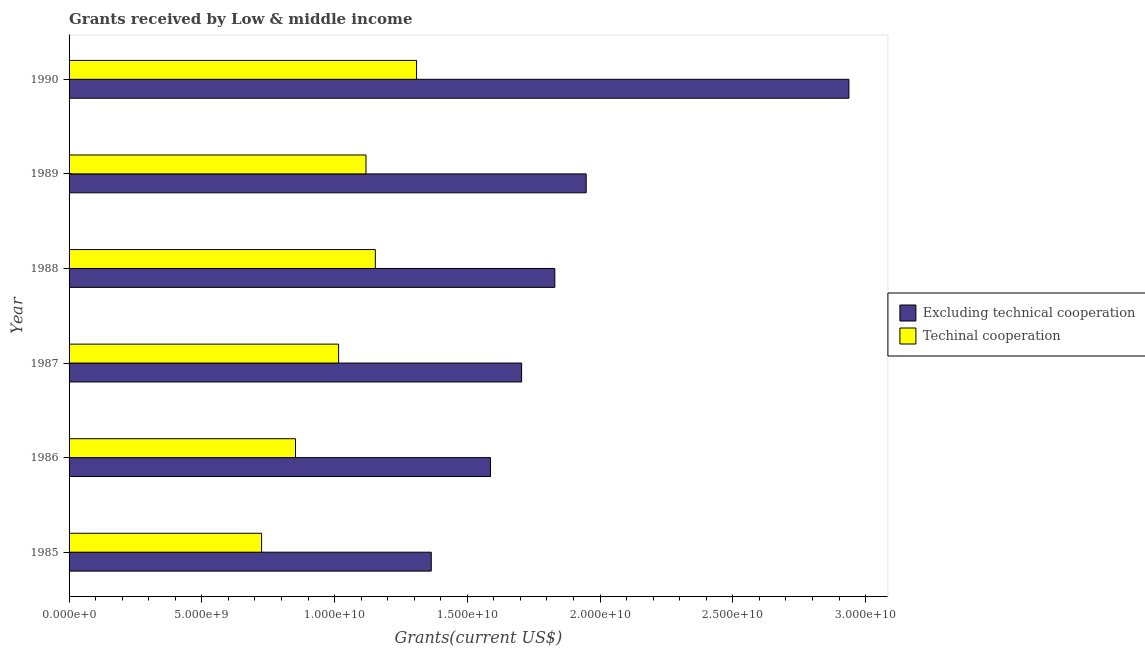How many different coloured bars are there?
Your response must be concise. 2. How many groups of bars are there?
Your answer should be very brief. 6. In how many cases, is the number of bars for a given year not equal to the number of legend labels?
Your response must be concise. 0. What is the amount of grants received(including technical cooperation) in 1988?
Keep it short and to the point. 1.15e+1. Across all years, what is the maximum amount of grants received(including technical cooperation)?
Your answer should be very brief. 1.31e+1. Across all years, what is the minimum amount of grants received(excluding technical cooperation)?
Provide a succinct answer. 1.36e+1. In which year was the amount of grants received(including technical cooperation) maximum?
Provide a short and direct response. 1990. What is the total amount of grants received(including technical cooperation) in the graph?
Offer a very short reply. 6.17e+1. What is the difference between the amount of grants received(including technical cooperation) in 1985 and that in 1989?
Ensure brevity in your answer.  -3.93e+09. What is the difference between the amount of grants received(excluding technical cooperation) in 1985 and the amount of grants received(including technical cooperation) in 1990?
Your response must be concise. 5.54e+08. What is the average amount of grants received(excluding technical cooperation) per year?
Provide a succinct answer. 1.89e+1. In the year 1989, what is the difference between the amount of grants received(including technical cooperation) and amount of grants received(excluding technical cooperation)?
Provide a succinct answer. -8.29e+09. What is the ratio of the amount of grants received(excluding technical cooperation) in 1986 to that in 1990?
Make the answer very short. 0.54. Is the amount of grants received(including technical cooperation) in 1986 less than that in 1989?
Keep it short and to the point. Yes. Is the difference between the amount of grants received(including technical cooperation) in 1989 and 1990 greater than the difference between the amount of grants received(excluding technical cooperation) in 1989 and 1990?
Your answer should be very brief. Yes. What is the difference between the highest and the second highest amount of grants received(excluding technical cooperation)?
Ensure brevity in your answer.  9.90e+09. What is the difference between the highest and the lowest amount of grants received(excluding technical cooperation)?
Offer a terse response. 1.57e+1. Is the sum of the amount of grants received(including technical cooperation) in 1987 and 1990 greater than the maximum amount of grants received(excluding technical cooperation) across all years?
Give a very brief answer. No. What does the 1st bar from the top in 1987 represents?
Keep it short and to the point. Techinal cooperation. What does the 2nd bar from the bottom in 1988 represents?
Your answer should be compact. Techinal cooperation. How many bars are there?
Your answer should be compact. 12. How many years are there in the graph?
Provide a short and direct response. 6. Does the graph contain any zero values?
Offer a very short reply. No. Does the graph contain grids?
Ensure brevity in your answer.  No. Where does the legend appear in the graph?
Your answer should be very brief. Center right. What is the title of the graph?
Offer a terse response. Grants received by Low & middle income. Does "Largest city" appear as one of the legend labels in the graph?
Ensure brevity in your answer.  No. What is the label or title of the X-axis?
Make the answer very short. Grants(current US$). What is the Grants(current US$) in Excluding technical cooperation in 1985?
Provide a short and direct response. 1.36e+1. What is the Grants(current US$) in Techinal cooperation in 1985?
Give a very brief answer. 7.25e+09. What is the Grants(current US$) in Excluding technical cooperation in 1986?
Your answer should be compact. 1.59e+1. What is the Grants(current US$) in Techinal cooperation in 1986?
Your answer should be very brief. 8.53e+09. What is the Grants(current US$) in Excluding technical cooperation in 1987?
Give a very brief answer. 1.70e+1. What is the Grants(current US$) of Techinal cooperation in 1987?
Provide a succinct answer. 1.02e+1. What is the Grants(current US$) in Excluding technical cooperation in 1988?
Give a very brief answer. 1.83e+1. What is the Grants(current US$) in Techinal cooperation in 1988?
Your response must be concise. 1.15e+1. What is the Grants(current US$) of Excluding technical cooperation in 1989?
Offer a terse response. 1.95e+1. What is the Grants(current US$) in Techinal cooperation in 1989?
Make the answer very short. 1.12e+1. What is the Grants(current US$) in Excluding technical cooperation in 1990?
Offer a terse response. 2.94e+1. What is the Grants(current US$) of Techinal cooperation in 1990?
Keep it short and to the point. 1.31e+1. Across all years, what is the maximum Grants(current US$) in Excluding technical cooperation?
Ensure brevity in your answer.  2.94e+1. Across all years, what is the maximum Grants(current US$) in Techinal cooperation?
Provide a short and direct response. 1.31e+1. Across all years, what is the minimum Grants(current US$) of Excluding technical cooperation?
Offer a terse response. 1.36e+1. Across all years, what is the minimum Grants(current US$) of Techinal cooperation?
Your answer should be compact. 7.25e+09. What is the total Grants(current US$) of Excluding technical cooperation in the graph?
Ensure brevity in your answer.  1.14e+11. What is the total Grants(current US$) of Techinal cooperation in the graph?
Give a very brief answer. 6.17e+1. What is the difference between the Grants(current US$) of Excluding technical cooperation in 1985 and that in 1986?
Your answer should be compact. -2.23e+09. What is the difference between the Grants(current US$) in Techinal cooperation in 1985 and that in 1986?
Offer a very short reply. -1.28e+09. What is the difference between the Grants(current US$) in Excluding technical cooperation in 1985 and that in 1987?
Provide a short and direct response. -3.40e+09. What is the difference between the Grants(current US$) of Techinal cooperation in 1985 and that in 1987?
Make the answer very short. -2.90e+09. What is the difference between the Grants(current US$) in Excluding technical cooperation in 1985 and that in 1988?
Provide a short and direct response. -4.65e+09. What is the difference between the Grants(current US$) of Techinal cooperation in 1985 and that in 1988?
Make the answer very short. -4.28e+09. What is the difference between the Grants(current US$) in Excluding technical cooperation in 1985 and that in 1989?
Give a very brief answer. -5.83e+09. What is the difference between the Grants(current US$) of Techinal cooperation in 1985 and that in 1989?
Your answer should be compact. -3.93e+09. What is the difference between the Grants(current US$) of Excluding technical cooperation in 1985 and that in 1990?
Make the answer very short. -1.57e+1. What is the difference between the Grants(current US$) of Techinal cooperation in 1985 and that in 1990?
Ensure brevity in your answer.  -5.84e+09. What is the difference between the Grants(current US$) of Excluding technical cooperation in 1986 and that in 1987?
Your answer should be compact. -1.17e+09. What is the difference between the Grants(current US$) of Techinal cooperation in 1986 and that in 1987?
Make the answer very short. -1.62e+09. What is the difference between the Grants(current US$) in Excluding technical cooperation in 1986 and that in 1988?
Your answer should be very brief. -2.42e+09. What is the difference between the Grants(current US$) of Techinal cooperation in 1986 and that in 1988?
Make the answer very short. -3.01e+09. What is the difference between the Grants(current US$) of Excluding technical cooperation in 1986 and that in 1989?
Offer a terse response. -3.60e+09. What is the difference between the Grants(current US$) of Techinal cooperation in 1986 and that in 1989?
Keep it short and to the point. -2.65e+09. What is the difference between the Grants(current US$) of Excluding technical cooperation in 1986 and that in 1990?
Your response must be concise. -1.35e+1. What is the difference between the Grants(current US$) of Techinal cooperation in 1986 and that in 1990?
Give a very brief answer. -4.56e+09. What is the difference between the Grants(current US$) of Excluding technical cooperation in 1987 and that in 1988?
Your response must be concise. -1.25e+09. What is the difference between the Grants(current US$) in Techinal cooperation in 1987 and that in 1988?
Provide a succinct answer. -1.38e+09. What is the difference between the Grants(current US$) in Excluding technical cooperation in 1987 and that in 1989?
Your response must be concise. -2.43e+09. What is the difference between the Grants(current US$) of Techinal cooperation in 1987 and that in 1989?
Your answer should be compact. -1.03e+09. What is the difference between the Grants(current US$) in Excluding technical cooperation in 1987 and that in 1990?
Your answer should be compact. -1.23e+1. What is the difference between the Grants(current US$) of Techinal cooperation in 1987 and that in 1990?
Offer a very short reply. -2.94e+09. What is the difference between the Grants(current US$) of Excluding technical cooperation in 1988 and that in 1989?
Your response must be concise. -1.18e+09. What is the difference between the Grants(current US$) in Techinal cooperation in 1988 and that in 1989?
Keep it short and to the point. 3.52e+08. What is the difference between the Grants(current US$) in Excluding technical cooperation in 1988 and that in 1990?
Ensure brevity in your answer.  -1.11e+1. What is the difference between the Grants(current US$) of Techinal cooperation in 1988 and that in 1990?
Make the answer very short. -1.55e+09. What is the difference between the Grants(current US$) of Excluding technical cooperation in 1989 and that in 1990?
Give a very brief answer. -9.90e+09. What is the difference between the Grants(current US$) in Techinal cooperation in 1989 and that in 1990?
Offer a terse response. -1.91e+09. What is the difference between the Grants(current US$) in Excluding technical cooperation in 1985 and the Grants(current US$) in Techinal cooperation in 1986?
Give a very brief answer. 5.11e+09. What is the difference between the Grants(current US$) of Excluding technical cooperation in 1985 and the Grants(current US$) of Techinal cooperation in 1987?
Your answer should be compact. 3.49e+09. What is the difference between the Grants(current US$) in Excluding technical cooperation in 1985 and the Grants(current US$) in Techinal cooperation in 1988?
Give a very brief answer. 2.11e+09. What is the difference between the Grants(current US$) of Excluding technical cooperation in 1985 and the Grants(current US$) of Techinal cooperation in 1989?
Offer a terse response. 2.46e+09. What is the difference between the Grants(current US$) in Excluding technical cooperation in 1985 and the Grants(current US$) in Techinal cooperation in 1990?
Provide a short and direct response. 5.54e+08. What is the difference between the Grants(current US$) in Excluding technical cooperation in 1986 and the Grants(current US$) in Techinal cooperation in 1987?
Your answer should be very brief. 5.72e+09. What is the difference between the Grants(current US$) of Excluding technical cooperation in 1986 and the Grants(current US$) of Techinal cooperation in 1988?
Keep it short and to the point. 4.34e+09. What is the difference between the Grants(current US$) in Excluding technical cooperation in 1986 and the Grants(current US$) in Techinal cooperation in 1989?
Your response must be concise. 4.69e+09. What is the difference between the Grants(current US$) of Excluding technical cooperation in 1986 and the Grants(current US$) of Techinal cooperation in 1990?
Keep it short and to the point. 2.78e+09. What is the difference between the Grants(current US$) of Excluding technical cooperation in 1987 and the Grants(current US$) of Techinal cooperation in 1988?
Keep it short and to the point. 5.51e+09. What is the difference between the Grants(current US$) of Excluding technical cooperation in 1987 and the Grants(current US$) of Techinal cooperation in 1989?
Give a very brief answer. 5.86e+09. What is the difference between the Grants(current US$) of Excluding technical cooperation in 1987 and the Grants(current US$) of Techinal cooperation in 1990?
Provide a succinct answer. 3.96e+09. What is the difference between the Grants(current US$) in Excluding technical cooperation in 1988 and the Grants(current US$) in Techinal cooperation in 1989?
Your answer should be compact. 7.11e+09. What is the difference between the Grants(current US$) of Excluding technical cooperation in 1988 and the Grants(current US$) of Techinal cooperation in 1990?
Make the answer very short. 5.21e+09. What is the difference between the Grants(current US$) of Excluding technical cooperation in 1989 and the Grants(current US$) of Techinal cooperation in 1990?
Keep it short and to the point. 6.39e+09. What is the average Grants(current US$) of Excluding technical cooperation per year?
Offer a terse response. 1.89e+1. What is the average Grants(current US$) of Techinal cooperation per year?
Keep it short and to the point. 1.03e+1. In the year 1985, what is the difference between the Grants(current US$) in Excluding technical cooperation and Grants(current US$) in Techinal cooperation?
Your answer should be very brief. 6.39e+09. In the year 1986, what is the difference between the Grants(current US$) in Excluding technical cooperation and Grants(current US$) in Techinal cooperation?
Provide a succinct answer. 7.34e+09. In the year 1987, what is the difference between the Grants(current US$) of Excluding technical cooperation and Grants(current US$) of Techinal cooperation?
Your response must be concise. 6.89e+09. In the year 1988, what is the difference between the Grants(current US$) of Excluding technical cooperation and Grants(current US$) of Techinal cooperation?
Your answer should be very brief. 6.76e+09. In the year 1989, what is the difference between the Grants(current US$) in Excluding technical cooperation and Grants(current US$) in Techinal cooperation?
Provide a short and direct response. 8.29e+09. In the year 1990, what is the difference between the Grants(current US$) in Excluding technical cooperation and Grants(current US$) in Techinal cooperation?
Give a very brief answer. 1.63e+1. What is the ratio of the Grants(current US$) in Excluding technical cooperation in 1985 to that in 1986?
Offer a very short reply. 0.86. What is the ratio of the Grants(current US$) in Techinal cooperation in 1985 to that in 1986?
Provide a succinct answer. 0.85. What is the ratio of the Grants(current US$) in Excluding technical cooperation in 1985 to that in 1987?
Give a very brief answer. 0.8. What is the ratio of the Grants(current US$) in Techinal cooperation in 1985 to that in 1987?
Your response must be concise. 0.71. What is the ratio of the Grants(current US$) in Excluding technical cooperation in 1985 to that in 1988?
Offer a very short reply. 0.75. What is the ratio of the Grants(current US$) in Techinal cooperation in 1985 to that in 1988?
Your answer should be very brief. 0.63. What is the ratio of the Grants(current US$) of Excluding technical cooperation in 1985 to that in 1989?
Provide a succinct answer. 0.7. What is the ratio of the Grants(current US$) in Techinal cooperation in 1985 to that in 1989?
Ensure brevity in your answer.  0.65. What is the ratio of the Grants(current US$) in Excluding technical cooperation in 1985 to that in 1990?
Provide a succinct answer. 0.46. What is the ratio of the Grants(current US$) of Techinal cooperation in 1985 to that in 1990?
Provide a succinct answer. 0.55. What is the ratio of the Grants(current US$) in Excluding technical cooperation in 1986 to that in 1987?
Make the answer very short. 0.93. What is the ratio of the Grants(current US$) of Techinal cooperation in 1986 to that in 1987?
Provide a succinct answer. 0.84. What is the ratio of the Grants(current US$) of Excluding technical cooperation in 1986 to that in 1988?
Provide a succinct answer. 0.87. What is the ratio of the Grants(current US$) in Techinal cooperation in 1986 to that in 1988?
Keep it short and to the point. 0.74. What is the ratio of the Grants(current US$) of Excluding technical cooperation in 1986 to that in 1989?
Make the answer very short. 0.81. What is the ratio of the Grants(current US$) of Techinal cooperation in 1986 to that in 1989?
Keep it short and to the point. 0.76. What is the ratio of the Grants(current US$) in Excluding technical cooperation in 1986 to that in 1990?
Offer a terse response. 0.54. What is the ratio of the Grants(current US$) of Techinal cooperation in 1986 to that in 1990?
Offer a terse response. 0.65. What is the ratio of the Grants(current US$) in Excluding technical cooperation in 1987 to that in 1988?
Offer a very short reply. 0.93. What is the ratio of the Grants(current US$) of Techinal cooperation in 1987 to that in 1988?
Offer a terse response. 0.88. What is the ratio of the Grants(current US$) of Excluding technical cooperation in 1987 to that in 1989?
Keep it short and to the point. 0.88. What is the ratio of the Grants(current US$) in Techinal cooperation in 1987 to that in 1989?
Your response must be concise. 0.91. What is the ratio of the Grants(current US$) of Excluding technical cooperation in 1987 to that in 1990?
Keep it short and to the point. 0.58. What is the ratio of the Grants(current US$) of Techinal cooperation in 1987 to that in 1990?
Ensure brevity in your answer.  0.78. What is the ratio of the Grants(current US$) in Excluding technical cooperation in 1988 to that in 1989?
Offer a terse response. 0.94. What is the ratio of the Grants(current US$) in Techinal cooperation in 1988 to that in 1989?
Offer a terse response. 1.03. What is the ratio of the Grants(current US$) of Excluding technical cooperation in 1988 to that in 1990?
Your response must be concise. 0.62. What is the ratio of the Grants(current US$) in Techinal cooperation in 1988 to that in 1990?
Offer a terse response. 0.88. What is the ratio of the Grants(current US$) of Excluding technical cooperation in 1989 to that in 1990?
Your answer should be very brief. 0.66. What is the ratio of the Grants(current US$) in Techinal cooperation in 1989 to that in 1990?
Your answer should be very brief. 0.85. What is the difference between the highest and the second highest Grants(current US$) in Excluding technical cooperation?
Your response must be concise. 9.90e+09. What is the difference between the highest and the second highest Grants(current US$) of Techinal cooperation?
Make the answer very short. 1.55e+09. What is the difference between the highest and the lowest Grants(current US$) in Excluding technical cooperation?
Offer a terse response. 1.57e+1. What is the difference between the highest and the lowest Grants(current US$) of Techinal cooperation?
Your response must be concise. 5.84e+09. 